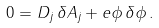Convert formula to latex. <formula><loc_0><loc_0><loc_500><loc_500>0 = D _ { j } \, \delta A _ { j } + e \phi \, \delta \phi \, .</formula> 